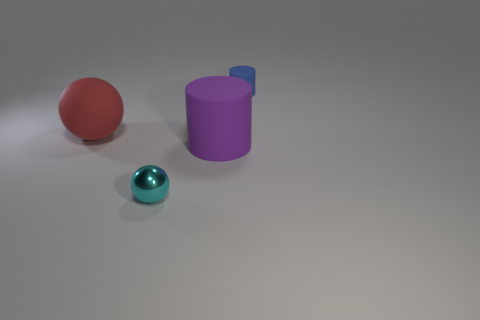There is a large object to the right of the large red rubber sphere; what is its shape?
Your response must be concise. Cylinder. What number of cyan objects are shiny spheres or large rubber things?
Give a very brief answer. 1. What is the color of the other cylinder that is made of the same material as the small cylinder?
Offer a very short reply. Purple. Do the large ball and the thing behind the matte ball have the same color?
Offer a very short reply. No. The object that is behind the metal thing and on the left side of the purple cylinder is what color?
Ensure brevity in your answer.  Red. There is a large red sphere; how many purple things are in front of it?
Offer a terse response. 1. How many objects are brown cylinders or small objects behind the purple thing?
Provide a short and direct response. 1. There is a big matte thing that is left of the metal object; is there a cyan thing that is on the left side of it?
Make the answer very short. No. The cylinder that is in front of the blue thing is what color?
Ensure brevity in your answer.  Purple. Are there an equal number of large red matte spheres that are to the right of the tiny cyan thing and blue cylinders?
Your answer should be compact. No. 